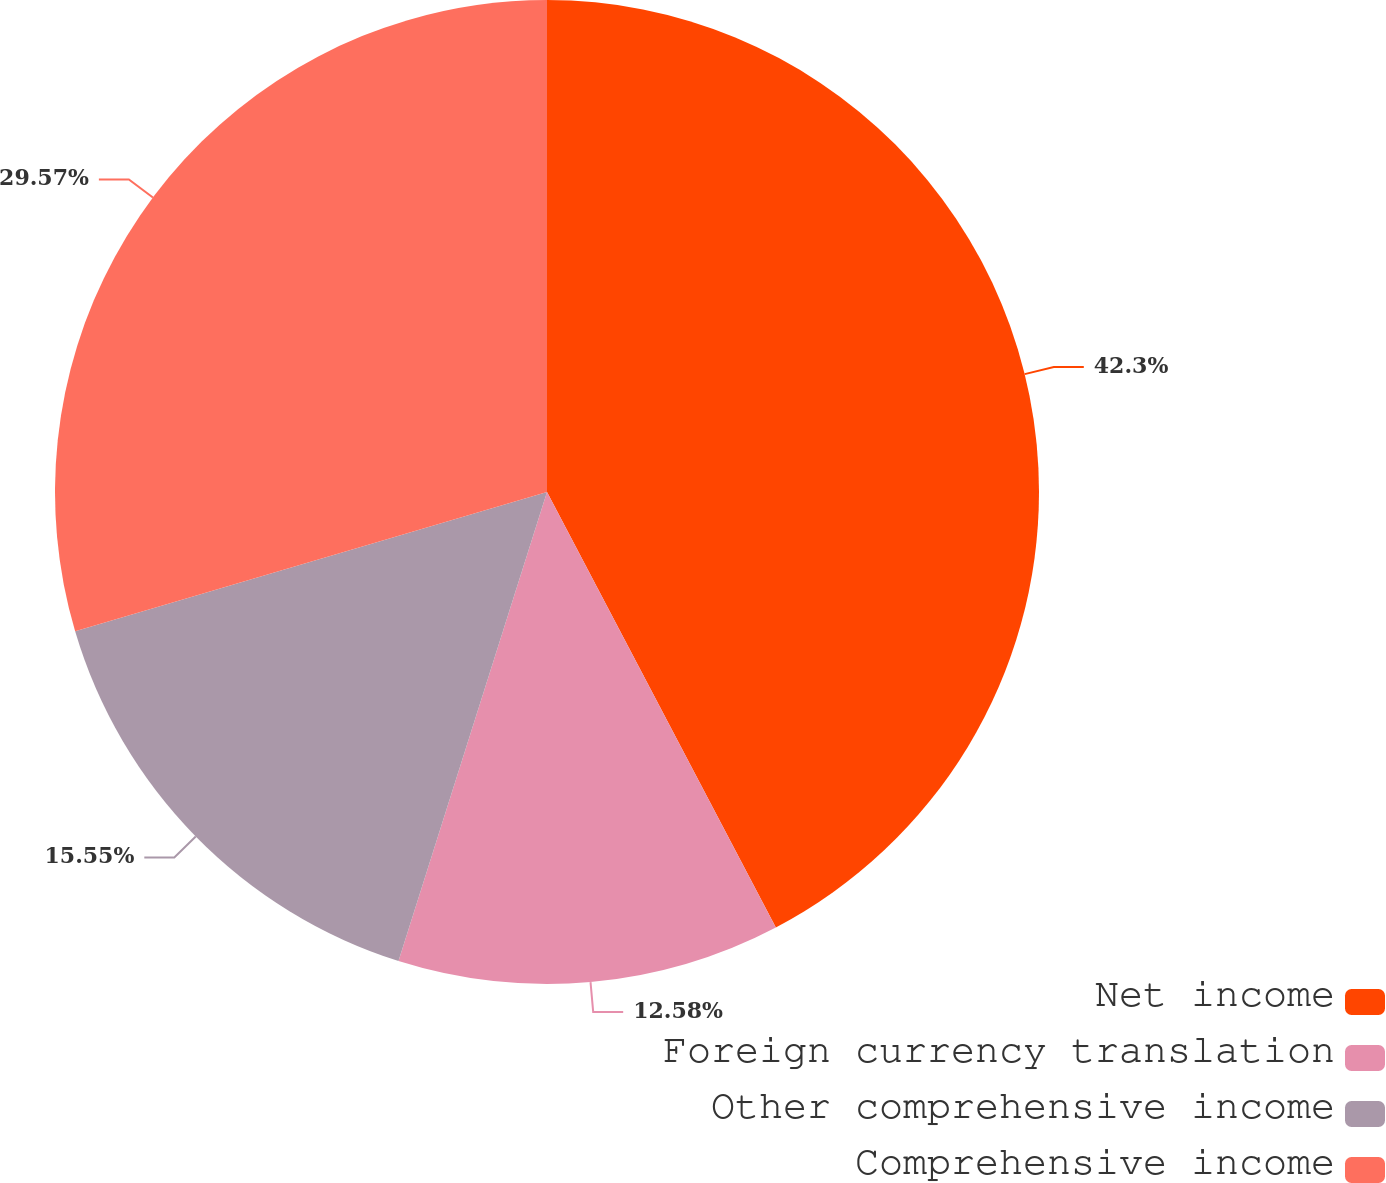Convert chart to OTSL. <chart><loc_0><loc_0><loc_500><loc_500><pie_chart><fcel>Net income<fcel>Foreign currency translation<fcel>Other comprehensive income<fcel>Comprehensive income<nl><fcel>42.3%<fcel>12.58%<fcel>15.55%<fcel>29.57%<nl></chart> 